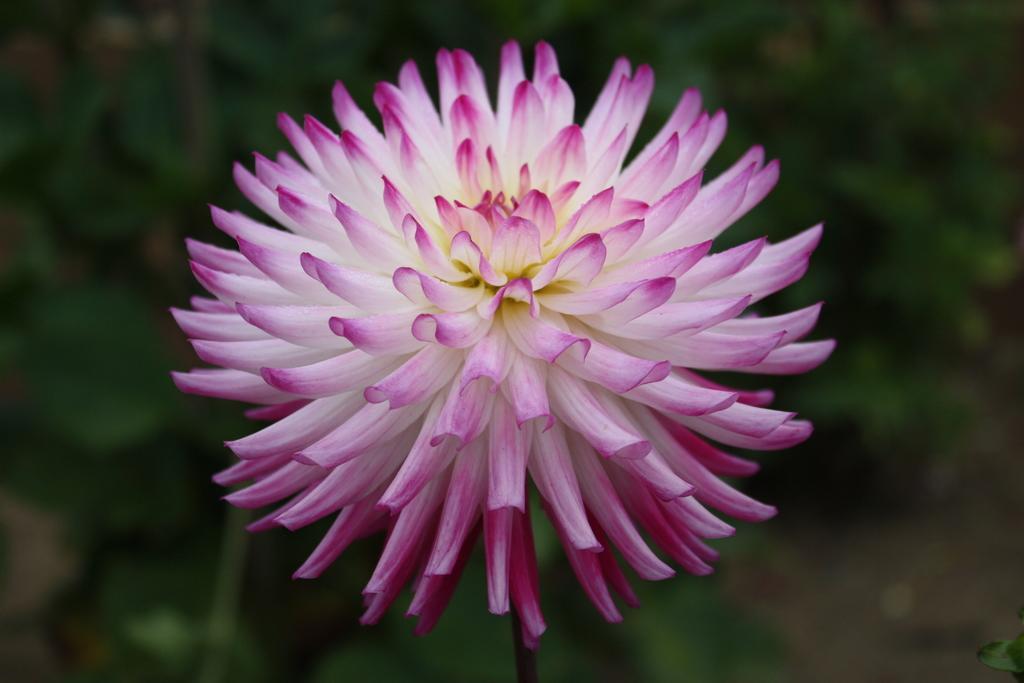How would you summarize this image in a sentence or two? It is a beautiful flower which is in white and pink color. 